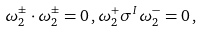<formula> <loc_0><loc_0><loc_500><loc_500>\omega ^ { \pm } _ { 2 } \cdot \omega ^ { \pm } _ { 2 } = 0 \, , \omega ^ { + } _ { 2 } \sigma ^ { I } \omega ^ { - } _ { 2 } = 0 \, ,</formula> 